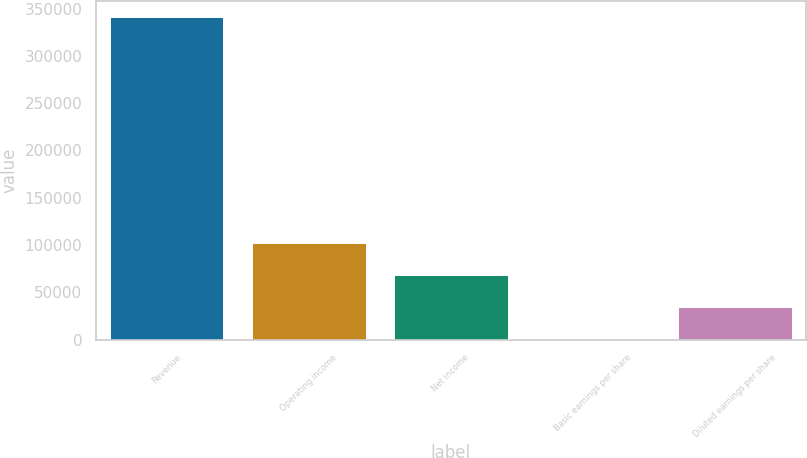<chart> <loc_0><loc_0><loc_500><loc_500><bar_chart><fcel>Revenue<fcel>Operating income<fcel>Net income<fcel>Basic earnings per share<fcel>Diluted earnings per share<nl><fcel>340754<fcel>102227<fcel>68151.4<fcel>0.74<fcel>34076.1<nl></chart> 